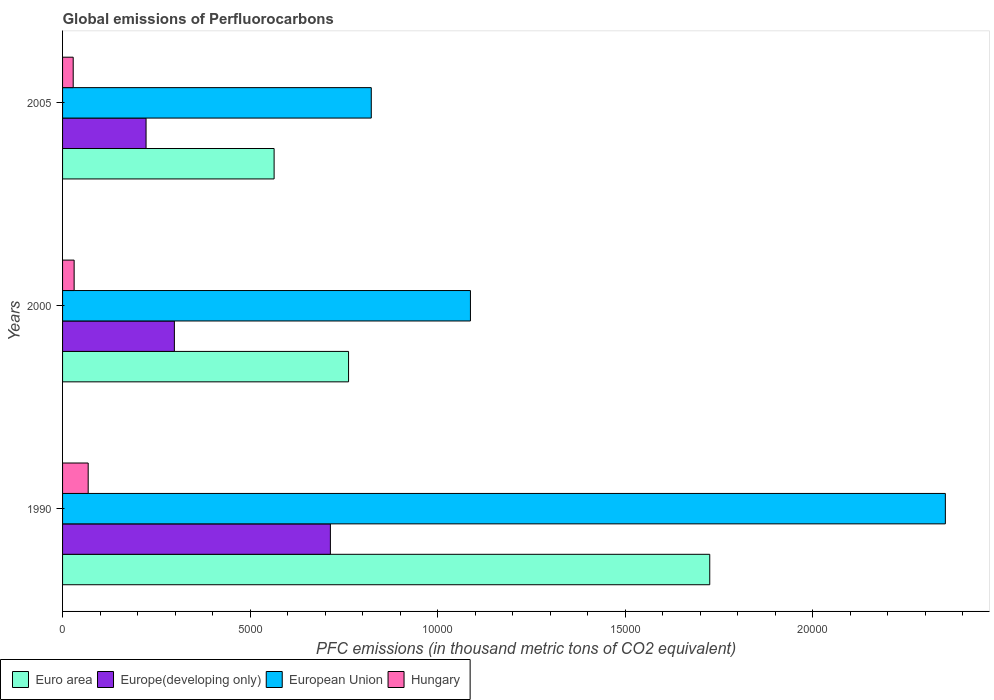How many different coloured bars are there?
Your answer should be very brief. 4. How many groups of bars are there?
Provide a short and direct response. 3. How many bars are there on the 1st tick from the bottom?
Make the answer very short. 4. What is the global emissions of Perfluorocarbons in Hungary in 2005?
Make the answer very short. 283.7. Across all years, what is the maximum global emissions of Perfluorocarbons in Euro area?
Make the answer very short. 1.73e+04. Across all years, what is the minimum global emissions of Perfluorocarbons in Hungary?
Your answer should be very brief. 283.7. In which year was the global emissions of Perfluorocarbons in Hungary maximum?
Ensure brevity in your answer.  1990. What is the total global emissions of Perfluorocarbons in Hungary in the graph?
Your response must be concise. 1275.5. What is the difference between the global emissions of Perfluorocarbons in European Union in 1990 and that in 2005?
Provide a short and direct response. 1.53e+04. What is the difference between the global emissions of Perfluorocarbons in Euro area in 1990 and the global emissions of Perfluorocarbons in European Union in 2005?
Ensure brevity in your answer.  9024.31. What is the average global emissions of Perfluorocarbons in European Union per year?
Make the answer very short. 1.42e+04. In the year 1990, what is the difference between the global emissions of Perfluorocarbons in European Union and global emissions of Perfluorocarbons in Europe(developing only)?
Provide a short and direct response. 1.64e+04. In how many years, is the global emissions of Perfluorocarbons in Hungary greater than 20000 thousand metric tons?
Make the answer very short. 0. What is the ratio of the global emissions of Perfluorocarbons in Hungary in 1990 to that in 2000?
Offer a very short reply. 2.21. Is the global emissions of Perfluorocarbons in Euro area in 2000 less than that in 2005?
Your answer should be compact. No. What is the difference between the highest and the second highest global emissions of Perfluorocarbons in Hungary?
Offer a very short reply. 374.8. What is the difference between the highest and the lowest global emissions of Perfluorocarbons in European Union?
Ensure brevity in your answer.  1.53e+04. In how many years, is the global emissions of Perfluorocarbons in Euro area greater than the average global emissions of Perfluorocarbons in Euro area taken over all years?
Keep it short and to the point. 1. What does the 3rd bar from the bottom in 1990 represents?
Offer a very short reply. European Union. Are all the bars in the graph horizontal?
Ensure brevity in your answer.  Yes. Where does the legend appear in the graph?
Provide a short and direct response. Bottom left. How are the legend labels stacked?
Make the answer very short. Horizontal. What is the title of the graph?
Your response must be concise. Global emissions of Perfluorocarbons. What is the label or title of the X-axis?
Provide a short and direct response. PFC emissions (in thousand metric tons of CO2 equivalent). What is the label or title of the Y-axis?
Your answer should be very brief. Years. What is the PFC emissions (in thousand metric tons of CO2 equivalent) in Euro area in 1990?
Offer a terse response. 1.73e+04. What is the PFC emissions (in thousand metric tons of CO2 equivalent) in Europe(developing only) in 1990?
Your answer should be compact. 7140.8. What is the PFC emissions (in thousand metric tons of CO2 equivalent) in European Union in 1990?
Keep it short and to the point. 2.35e+04. What is the PFC emissions (in thousand metric tons of CO2 equivalent) of Hungary in 1990?
Make the answer very short. 683.3. What is the PFC emissions (in thousand metric tons of CO2 equivalent) in Euro area in 2000?
Your answer should be very brief. 7625. What is the PFC emissions (in thousand metric tons of CO2 equivalent) in Europe(developing only) in 2000?
Make the answer very short. 2981.2. What is the PFC emissions (in thousand metric tons of CO2 equivalent) of European Union in 2000?
Offer a terse response. 1.09e+04. What is the PFC emissions (in thousand metric tons of CO2 equivalent) of Hungary in 2000?
Your response must be concise. 308.5. What is the PFC emissions (in thousand metric tons of CO2 equivalent) in Euro area in 2005?
Your response must be concise. 5640.06. What is the PFC emissions (in thousand metric tons of CO2 equivalent) in Europe(developing only) in 2005?
Your answer should be very brief. 2226.02. What is the PFC emissions (in thousand metric tons of CO2 equivalent) of European Union in 2005?
Keep it short and to the point. 8230.79. What is the PFC emissions (in thousand metric tons of CO2 equivalent) in Hungary in 2005?
Provide a succinct answer. 283.7. Across all years, what is the maximum PFC emissions (in thousand metric tons of CO2 equivalent) of Euro area?
Your answer should be compact. 1.73e+04. Across all years, what is the maximum PFC emissions (in thousand metric tons of CO2 equivalent) in Europe(developing only)?
Give a very brief answer. 7140.8. Across all years, what is the maximum PFC emissions (in thousand metric tons of CO2 equivalent) of European Union?
Offer a terse response. 2.35e+04. Across all years, what is the maximum PFC emissions (in thousand metric tons of CO2 equivalent) in Hungary?
Your answer should be very brief. 683.3. Across all years, what is the minimum PFC emissions (in thousand metric tons of CO2 equivalent) of Euro area?
Your answer should be compact. 5640.06. Across all years, what is the minimum PFC emissions (in thousand metric tons of CO2 equivalent) in Europe(developing only)?
Keep it short and to the point. 2226.02. Across all years, what is the minimum PFC emissions (in thousand metric tons of CO2 equivalent) in European Union?
Provide a short and direct response. 8230.79. Across all years, what is the minimum PFC emissions (in thousand metric tons of CO2 equivalent) of Hungary?
Provide a succinct answer. 283.7. What is the total PFC emissions (in thousand metric tons of CO2 equivalent) of Euro area in the graph?
Ensure brevity in your answer.  3.05e+04. What is the total PFC emissions (in thousand metric tons of CO2 equivalent) of Europe(developing only) in the graph?
Make the answer very short. 1.23e+04. What is the total PFC emissions (in thousand metric tons of CO2 equivalent) in European Union in the graph?
Keep it short and to the point. 4.26e+04. What is the total PFC emissions (in thousand metric tons of CO2 equivalent) in Hungary in the graph?
Your answer should be compact. 1275.5. What is the difference between the PFC emissions (in thousand metric tons of CO2 equivalent) of Euro area in 1990 and that in 2000?
Offer a very short reply. 9630.1. What is the difference between the PFC emissions (in thousand metric tons of CO2 equivalent) in Europe(developing only) in 1990 and that in 2000?
Provide a short and direct response. 4159.6. What is the difference between the PFC emissions (in thousand metric tons of CO2 equivalent) in European Union in 1990 and that in 2000?
Provide a short and direct response. 1.27e+04. What is the difference between the PFC emissions (in thousand metric tons of CO2 equivalent) of Hungary in 1990 and that in 2000?
Make the answer very short. 374.8. What is the difference between the PFC emissions (in thousand metric tons of CO2 equivalent) of Euro area in 1990 and that in 2005?
Your answer should be compact. 1.16e+04. What is the difference between the PFC emissions (in thousand metric tons of CO2 equivalent) in Europe(developing only) in 1990 and that in 2005?
Offer a terse response. 4914.78. What is the difference between the PFC emissions (in thousand metric tons of CO2 equivalent) of European Union in 1990 and that in 2005?
Provide a succinct answer. 1.53e+04. What is the difference between the PFC emissions (in thousand metric tons of CO2 equivalent) of Hungary in 1990 and that in 2005?
Keep it short and to the point. 399.6. What is the difference between the PFC emissions (in thousand metric tons of CO2 equivalent) of Euro area in 2000 and that in 2005?
Ensure brevity in your answer.  1984.94. What is the difference between the PFC emissions (in thousand metric tons of CO2 equivalent) in Europe(developing only) in 2000 and that in 2005?
Ensure brevity in your answer.  755.18. What is the difference between the PFC emissions (in thousand metric tons of CO2 equivalent) of European Union in 2000 and that in 2005?
Your response must be concise. 2643.81. What is the difference between the PFC emissions (in thousand metric tons of CO2 equivalent) in Hungary in 2000 and that in 2005?
Offer a terse response. 24.8. What is the difference between the PFC emissions (in thousand metric tons of CO2 equivalent) of Euro area in 1990 and the PFC emissions (in thousand metric tons of CO2 equivalent) of Europe(developing only) in 2000?
Offer a very short reply. 1.43e+04. What is the difference between the PFC emissions (in thousand metric tons of CO2 equivalent) of Euro area in 1990 and the PFC emissions (in thousand metric tons of CO2 equivalent) of European Union in 2000?
Your answer should be very brief. 6380.5. What is the difference between the PFC emissions (in thousand metric tons of CO2 equivalent) in Euro area in 1990 and the PFC emissions (in thousand metric tons of CO2 equivalent) in Hungary in 2000?
Ensure brevity in your answer.  1.69e+04. What is the difference between the PFC emissions (in thousand metric tons of CO2 equivalent) in Europe(developing only) in 1990 and the PFC emissions (in thousand metric tons of CO2 equivalent) in European Union in 2000?
Ensure brevity in your answer.  -3733.8. What is the difference between the PFC emissions (in thousand metric tons of CO2 equivalent) in Europe(developing only) in 1990 and the PFC emissions (in thousand metric tons of CO2 equivalent) in Hungary in 2000?
Give a very brief answer. 6832.3. What is the difference between the PFC emissions (in thousand metric tons of CO2 equivalent) in European Union in 1990 and the PFC emissions (in thousand metric tons of CO2 equivalent) in Hungary in 2000?
Provide a succinct answer. 2.32e+04. What is the difference between the PFC emissions (in thousand metric tons of CO2 equivalent) of Euro area in 1990 and the PFC emissions (in thousand metric tons of CO2 equivalent) of Europe(developing only) in 2005?
Give a very brief answer. 1.50e+04. What is the difference between the PFC emissions (in thousand metric tons of CO2 equivalent) in Euro area in 1990 and the PFC emissions (in thousand metric tons of CO2 equivalent) in European Union in 2005?
Keep it short and to the point. 9024.31. What is the difference between the PFC emissions (in thousand metric tons of CO2 equivalent) of Euro area in 1990 and the PFC emissions (in thousand metric tons of CO2 equivalent) of Hungary in 2005?
Offer a very short reply. 1.70e+04. What is the difference between the PFC emissions (in thousand metric tons of CO2 equivalent) in Europe(developing only) in 1990 and the PFC emissions (in thousand metric tons of CO2 equivalent) in European Union in 2005?
Your answer should be very brief. -1089.99. What is the difference between the PFC emissions (in thousand metric tons of CO2 equivalent) in Europe(developing only) in 1990 and the PFC emissions (in thousand metric tons of CO2 equivalent) in Hungary in 2005?
Ensure brevity in your answer.  6857.1. What is the difference between the PFC emissions (in thousand metric tons of CO2 equivalent) in European Union in 1990 and the PFC emissions (in thousand metric tons of CO2 equivalent) in Hungary in 2005?
Offer a terse response. 2.33e+04. What is the difference between the PFC emissions (in thousand metric tons of CO2 equivalent) in Euro area in 2000 and the PFC emissions (in thousand metric tons of CO2 equivalent) in Europe(developing only) in 2005?
Provide a succinct answer. 5398.98. What is the difference between the PFC emissions (in thousand metric tons of CO2 equivalent) of Euro area in 2000 and the PFC emissions (in thousand metric tons of CO2 equivalent) of European Union in 2005?
Provide a succinct answer. -605.79. What is the difference between the PFC emissions (in thousand metric tons of CO2 equivalent) of Euro area in 2000 and the PFC emissions (in thousand metric tons of CO2 equivalent) of Hungary in 2005?
Offer a terse response. 7341.3. What is the difference between the PFC emissions (in thousand metric tons of CO2 equivalent) in Europe(developing only) in 2000 and the PFC emissions (in thousand metric tons of CO2 equivalent) in European Union in 2005?
Provide a short and direct response. -5249.59. What is the difference between the PFC emissions (in thousand metric tons of CO2 equivalent) of Europe(developing only) in 2000 and the PFC emissions (in thousand metric tons of CO2 equivalent) of Hungary in 2005?
Your answer should be compact. 2697.5. What is the difference between the PFC emissions (in thousand metric tons of CO2 equivalent) of European Union in 2000 and the PFC emissions (in thousand metric tons of CO2 equivalent) of Hungary in 2005?
Make the answer very short. 1.06e+04. What is the average PFC emissions (in thousand metric tons of CO2 equivalent) of Euro area per year?
Make the answer very short. 1.02e+04. What is the average PFC emissions (in thousand metric tons of CO2 equivalent) of Europe(developing only) per year?
Provide a succinct answer. 4116.01. What is the average PFC emissions (in thousand metric tons of CO2 equivalent) in European Union per year?
Offer a terse response. 1.42e+04. What is the average PFC emissions (in thousand metric tons of CO2 equivalent) in Hungary per year?
Make the answer very short. 425.17. In the year 1990, what is the difference between the PFC emissions (in thousand metric tons of CO2 equivalent) in Euro area and PFC emissions (in thousand metric tons of CO2 equivalent) in Europe(developing only)?
Provide a short and direct response. 1.01e+04. In the year 1990, what is the difference between the PFC emissions (in thousand metric tons of CO2 equivalent) of Euro area and PFC emissions (in thousand metric tons of CO2 equivalent) of European Union?
Ensure brevity in your answer.  -6281.4. In the year 1990, what is the difference between the PFC emissions (in thousand metric tons of CO2 equivalent) of Euro area and PFC emissions (in thousand metric tons of CO2 equivalent) of Hungary?
Your answer should be very brief. 1.66e+04. In the year 1990, what is the difference between the PFC emissions (in thousand metric tons of CO2 equivalent) in Europe(developing only) and PFC emissions (in thousand metric tons of CO2 equivalent) in European Union?
Provide a succinct answer. -1.64e+04. In the year 1990, what is the difference between the PFC emissions (in thousand metric tons of CO2 equivalent) in Europe(developing only) and PFC emissions (in thousand metric tons of CO2 equivalent) in Hungary?
Make the answer very short. 6457.5. In the year 1990, what is the difference between the PFC emissions (in thousand metric tons of CO2 equivalent) of European Union and PFC emissions (in thousand metric tons of CO2 equivalent) of Hungary?
Keep it short and to the point. 2.29e+04. In the year 2000, what is the difference between the PFC emissions (in thousand metric tons of CO2 equivalent) of Euro area and PFC emissions (in thousand metric tons of CO2 equivalent) of Europe(developing only)?
Offer a very short reply. 4643.8. In the year 2000, what is the difference between the PFC emissions (in thousand metric tons of CO2 equivalent) of Euro area and PFC emissions (in thousand metric tons of CO2 equivalent) of European Union?
Provide a succinct answer. -3249.6. In the year 2000, what is the difference between the PFC emissions (in thousand metric tons of CO2 equivalent) of Euro area and PFC emissions (in thousand metric tons of CO2 equivalent) of Hungary?
Provide a succinct answer. 7316.5. In the year 2000, what is the difference between the PFC emissions (in thousand metric tons of CO2 equivalent) of Europe(developing only) and PFC emissions (in thousand metric tons of CO2 equivalent) of European Union?
Make the answer very short. -7893.4. In the year 2000, what is the difference between the PFC emissions (in thousand metric tons of CO2 equivalent) in Europe(developing only) and PFC emissions (in thousand metric tons of CO2 equivalent) in Hungary?
Keep it short and to the point. 2672.7. In the year 2000, what is the difference between the PFC emissions (in thousand metric tons of CO2 equivalent) of European Union and PFC emissions (in thousand metric tons of CO2 equivalent) of Hungary?
Ensure brevity in your answer.  1.06e+04. In the year 2005, what is the difference between the PFC emissions (in thousand metric tons of CO2 equivalent) in Euro area and PFC emissions (in thousand metric tons of CO2 equivalent) in Europe(developing only)?
Provide a succinct answer. 3414.03. In the year 2005, what is the difference between the PFC emissions (in thousand metric tons of CO2 equivalent) of Euro area and PFC emissions (in thousand metric tons of CO2 equivalent) of European Union?
Make the answer very short. -2590.74. In the year 2005, what is the difference between the PFC emissions (in thousand metric tons of CO2 equivalent) in Euro area and PFC emissions (in thousand metric tons of CO2 equivalent) in Hungary?
Offer a terse response. 5356.36. In the year 2005, what is the difference between the PFC emissions (in thousand metric tons of CO2 equivalent) of Europe(developing only) and PFC emissions (in thousand metric tons of CO2 equivalent) of European Union?
Make the answer very short. -6004.77. In the year 2005, what is the difference between the PFC emissions (in thousand metric tons of CO2 equivalent) of Europe(developing only) and PFC emissions (in thousand metric tons of CO2 equivalent) of Hungary?
Provide a short and direct response. 1942.32. In the year 2005, what is the difference between the PFC emissions (in thousand metric tons of CO2 equivalent) in European Union and PFC emissions (in thousand metric tons of CO2 equivalent) in Hungary?
Your response must be concise. 7947.09. What is the ratio of the PFC emissions (in thousand metric tons of CO2 equivalent) in Euro area in 1990 to that in 2000?
Give a very brief answer. 2.26. What is the ratio of the PFC emissions (in thousand metric tons of CO2 equivalent) of Europe(developing only) in 1990 to that in 2000?
Your answer should be very brief. 2.4. What is the ratio of the PFC emissions (in thousand metric tons of CO2 equivalent) of European Union in 1990 to that in 2000?
Your answer should be compact. 2.16. What is the ratio of the PFC emissions (in thousand metric tons of CO2 equivalent) of Hungary in 1990 to that in 2000?
Ensure brevity in your answer.  2.21. What is the ratio of the PFC emissions (in thousand metric tons of CO2 equivalent) in Euro area in 1990 to that in 2005?
Your answer should be compact. 3.06. What is the ratio of the PFC emissions (in thousand metric tons of CO2 equivalent) in Europe(developing only) in 1990 to that in 2005?
Your answer should be very brief. 3.21. What is the ratio of the PFC emissions (in thousand metric tons of CO2 equivalent) in European Union in 1990 to that in 2005?
Offer a very short reply. 2.86. What is the ratio of the PFC emissions (in thousand metric tons of CO2 equivalent) in Hungary in 1990 to that in 2005?
Offer a terse response. 2.41. What is the ratio of the PFC emissions (in thousand metric tons of CO2 equivalent) of Euro area in 2000 to that in 2005?
Provide a succinct answer. 1.35. What is the ratio of the PFC emissions (in thousand metric tons of CO2 equivalent) of Europe(developing only) in 2000 to that in 2005?
Keep it short and to the point. 1.34. What is the ratio of the PFC emissions (in thousand metric tons of CO2 equivalent) of European Union in 2000 to that in 2005?
Give a very brief answer. 1.32. What is the ratio of the PFC emissions (in thousand metric tons of CO2 equivalent) of Hungary in 2000 to that in 2005?
Provide a succinct answer. 1.09. What is the difference between the highest and the second highest PFC emissions (in thousand metric tons of CO2 equivalent) of Euro area?
Your answer should be very brief. 9630.1. What is the difference between the highest and the second highest PFC emissions (in thousand metric tons of CO2 equivalent) of Europe(developing only)?
Offer a terse response. 4159.6. What is the difference between the highest and the second highest PFC emissions (in thousand metric tons of CO2 equivalent) in European Union?
Offer a very short reply. 1.27e+04. What is the difference between the highest and the second highest PFC emissions (in thousand metric tons of CO2 equivalent) in Hungary?
Your answer should be very brief. 374.8. What is the difference between the highest and the lowest PFC emissions (in thousand metric tons of CO2 equivalent) of Euro area?
Keep it short and to the point. 1.16e+04. What is the difference between the highest and the lowest PFC emissions (in thousand metric tons of CO2 equivalent) of Europe(developing only)?
Make the answer very short. 4914.78. What is the difference between the highest and the lowest PFC emissions (in thousand metric tons of CO2 equivalent) of European Union?
Provide a succinct answer. 1.53e+04. What is the difference between the highest and the lowest PFC emissions (in thousand metric tons of CO2 equivalent) of Hungary?
Keep it short and to the point. 399.6. 